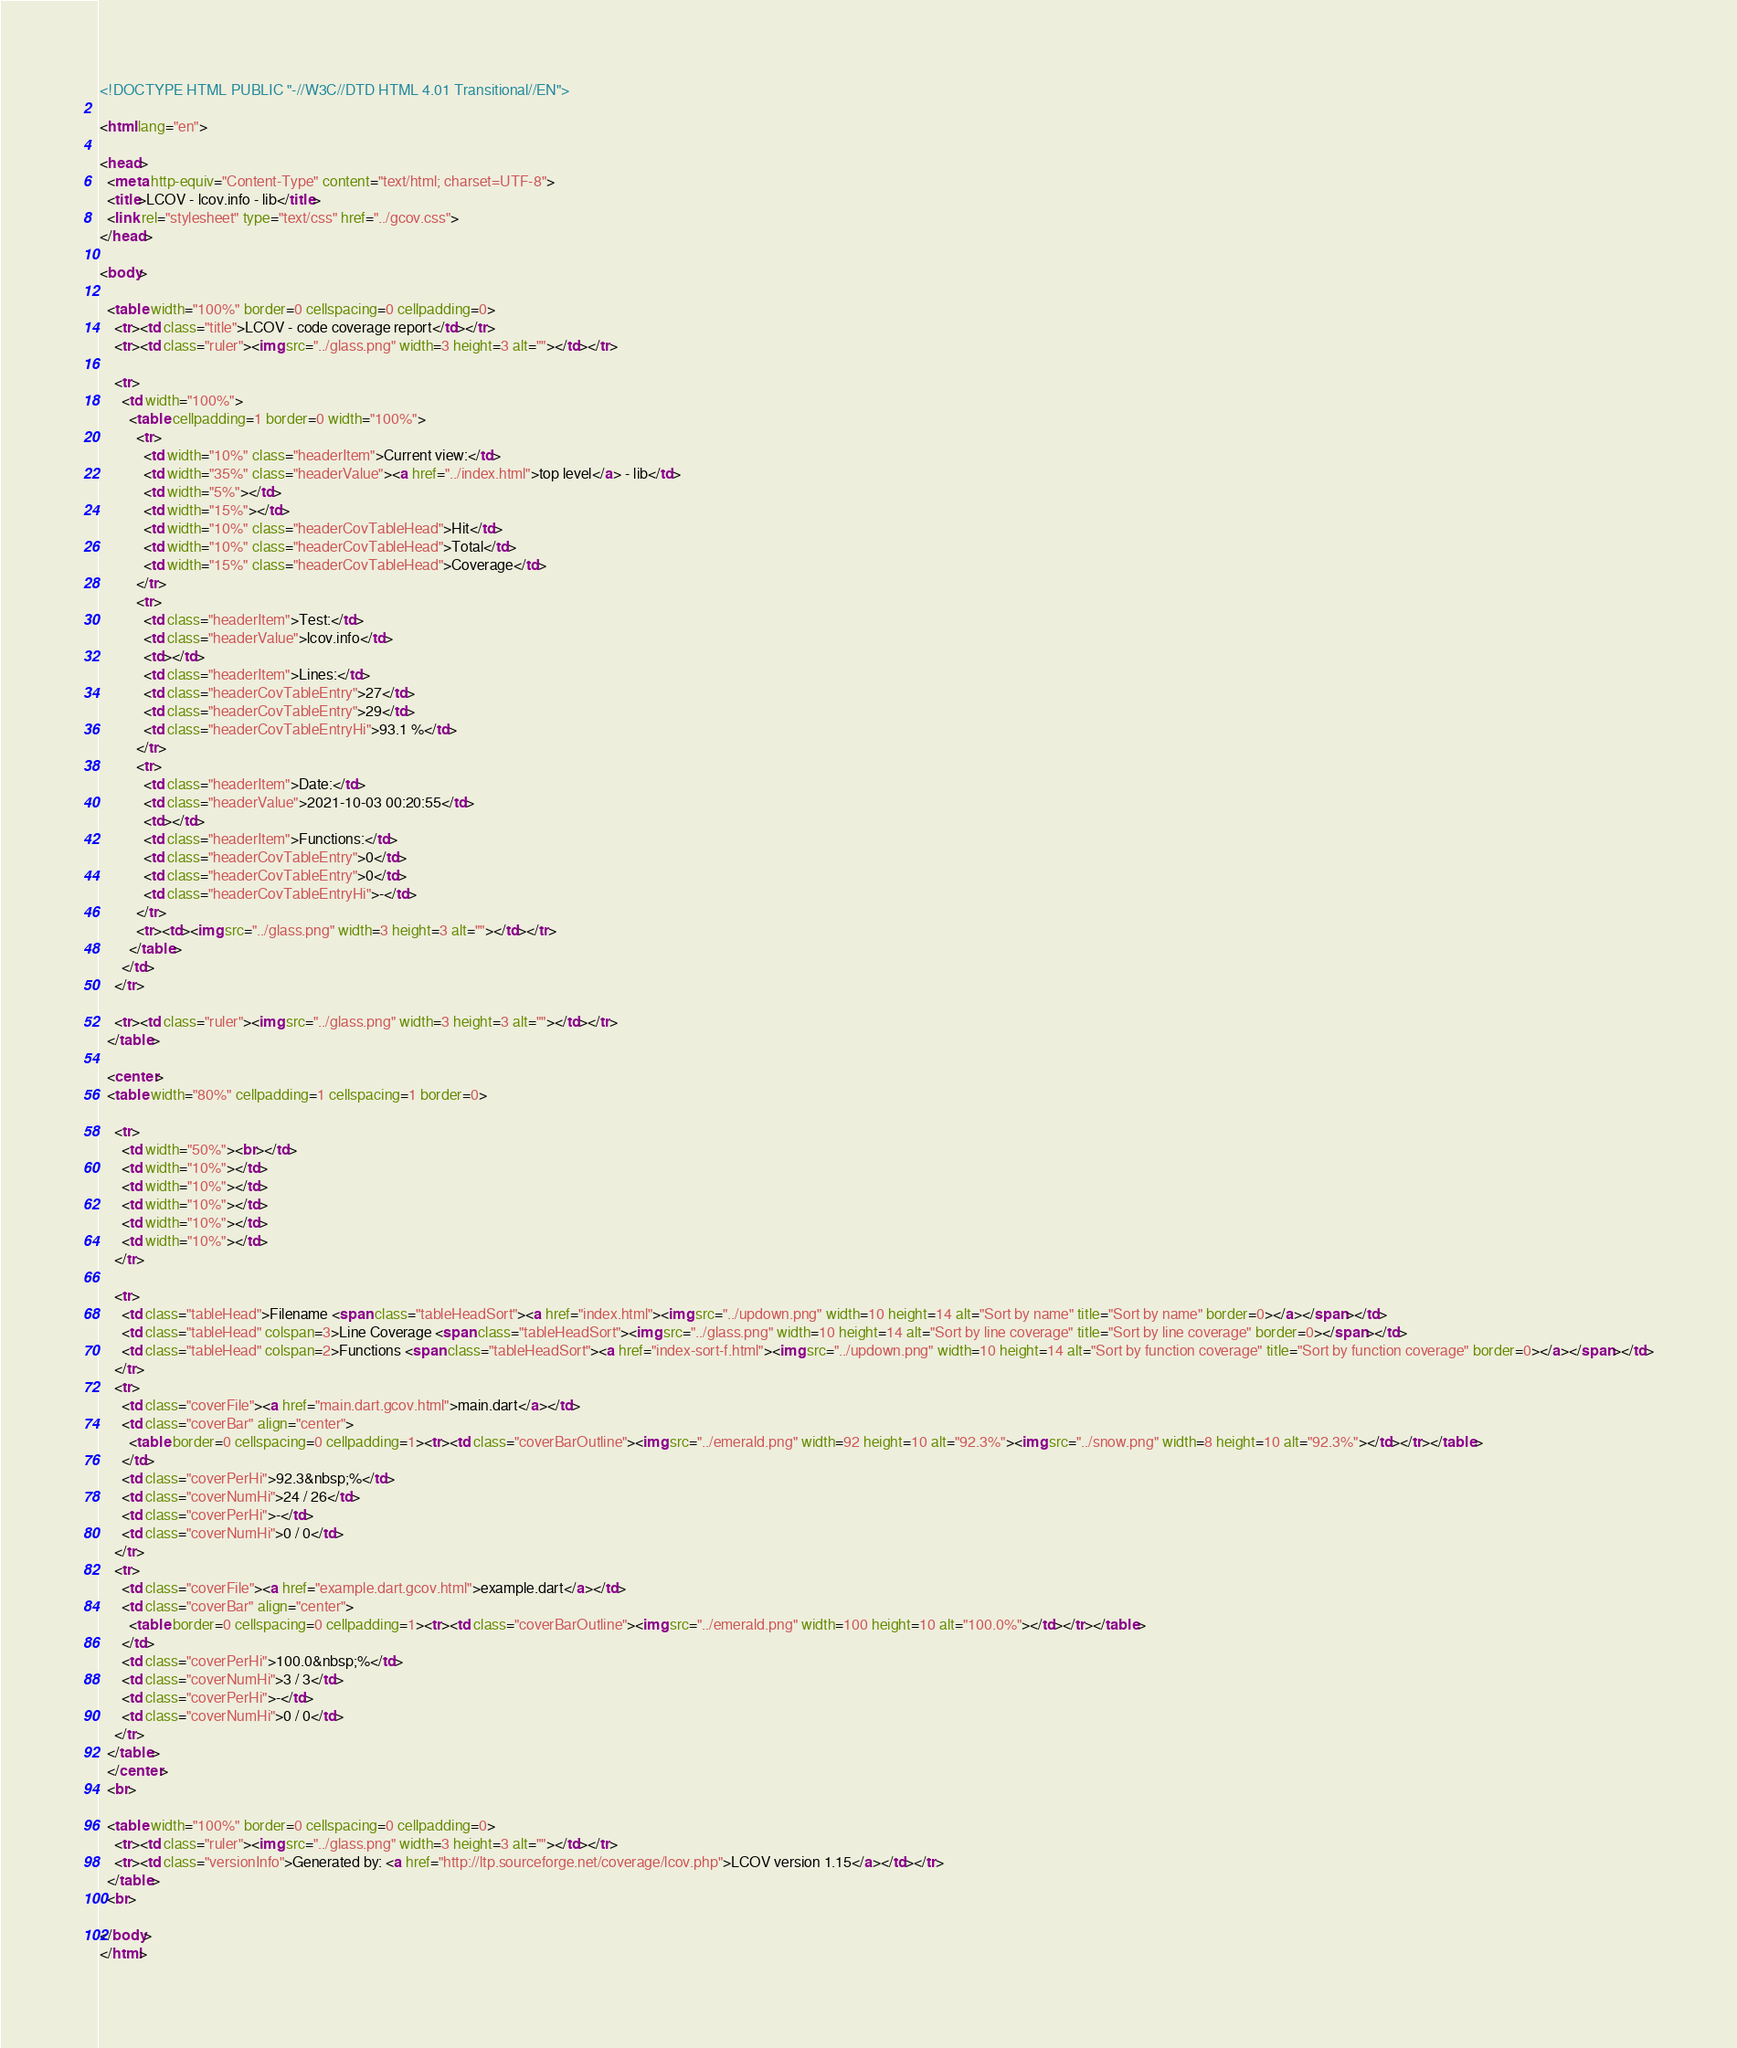Convert code to text. <code><loc_0><loc_0><loc_500><loc_500><_HTML_><!DOCTYPE HTML PUBLIC "-//W3C//DTD HTML 4.01 Transitional//EN">

<html lang="en">

<head>
  <meta http-equiv="Content-Type" content="text/html; charset=UTF-8">
  <title>LCOV - lcov.info - lib</title>
  <link rel="stylesheet" type="text/css" href="../gcov.css">
</head>

<body>

  <table width="100%" border=0 cellspacing=0 cellpadding=0>
    <tr><td class="title">LCOV - code coverage report</td></tr>
    <tr><td class="ruler"><img src="../glass.png" width=3 height=3 alt=""></td></tr>

    <tr>
      <td width="100%">
        <table cellpadding=1 border=0 width="100%">
          <tr>
            <td width="10%" class="headerItem">Current view:</td>
            <td width="35%" class="headerValue"><a href="../index.html">top level</a> - lib</td>
            <td width="5%"></td>
            <td width="15%"></td>
            <td width="10%" class="headerCovTableHead">Hit</td>
            <td width="10%" class="headerCovTableHead">Total</td>
            <td width="15%" class="headerCovTableHead">Coverage</td>
          </tr>
          <tr>
            <td class="headerItem">Test:</td>
            <td class="headerValue">lcov.info</td>
            <td></td>
            <td class="headerItem">Lines:</td>
            <td class="headerCovTableEntry">27</td>
            <td class="headerCovTableEntry">29</td>
            <td class="headerCovTableEntryHi">93.1 %</td>
          </tr>
          <tr>
            <td class="headerItem">Date:</td>
            <td class="headerValue">2021-10-03 00:20:55</td>
            <td></td>
            <td class="headerItem">Functions:</td>
            <td class="headerCovTableEntry">0</td>
            <td class="headerCovTableEntry">0</td>
            <td class="headerCovTableEntryHi">-</td>
          </tr>
          <tr><td><img src="../glass.png" width=3 height=3 alt=""></td></tr>
        </table>
      </td>
    </tr>

    <tr><td class="ruler"><img src="../glass.png" width=3 height=3 alt=""></td></tr>
  </table>

  <center>
  <table width="80%" cellpadding=1 cellspacing=1 border=0>

    <tr>
      <td width="50%"><br></td>
      <td width="10%"></td>
      <td width="10%"></td>
      <td width="10%"></td>
      <td width="10%"></td>
      <td width="10%"></td>
    </tr>

    <tr>
      <td class="tableHead">Filename <span class="tableHeadSort"><a href="index.html"><img src="../updown.png" width=10 height=14 alt="Sort by name" title="Sort by name" border=0></a></span></td>
      <td class="tableHead" colspan=3>Line Coverage <span class="tableHeadSort"><img src="../glass.png" width=10 height=14 alt="Sort by line coverage" title="Sort by line coverage" border=0></span></td>
      <td class="tableHead" colspan=2>Functions <span class="tableHeadSort"><a href="index-sort-f.html"><img src="../updown.png" width=10 height=14 alt="Sort by function coverage" title="Sort by function coverage" border=0></a></span></td>
    </tr>
    <tr>
      <td class="coverFile"><a href="main.dart.gcov.html">main.dart</a></td>
      <td class="coverBar" align="center">
        <table border=0 cellspacing=0 cellpadding=1><tr><td class="coverBarOutline"><img src="../emerald.png" width=92 height=10 alt="92.3%"><img src="../snow.png" width=8 height=10 alt="92.3%"></td></tr></table>
      </td>
      <td class="coverPerHi">92.3&nbsp;%</td>
      <td class="coverNumHi">24 / 26</td>
      <td class="coverPerHi">-</td>
      <td class="coverNumHi">0 / 0</td>
    </tr>
    <tr>
      <td class="coverFile"><a href="example.dart.gcov.html">example.dart</a></td>
      <td class="coverBar" align="center">
        <table border=0 cellspacing=0 cellpadding=1><tr><td class="coverBarOutline"><img src="../emerald.png" width=100 height=10 alt="100.0%"></td></tr></table>
      </td>
      <td class="coverPerHi">100.0&nbsp;%</td>
      <td class="coverNumHi">3 / 3</td>
      <td class="coverPerHi">-</td>
      <td class="coverNumHi">0 / 0</td>
    </tr>
  </table>
  </center>
  <br>

  <table width="100%" border=0 cellspacing=0 cellpadding=0>
    <tr><td class="ruler"><img src="../glass.png" width=3 height=3 alt=""></td></tr>
    <tr><td class="versionInfo">Generated by: <a href="http://ltp.sourceforge.net/coverage/lcov.php">LCOV version 1.15</a></td></tr>
  </table>
  <br>

</body>
</html>
</code> 